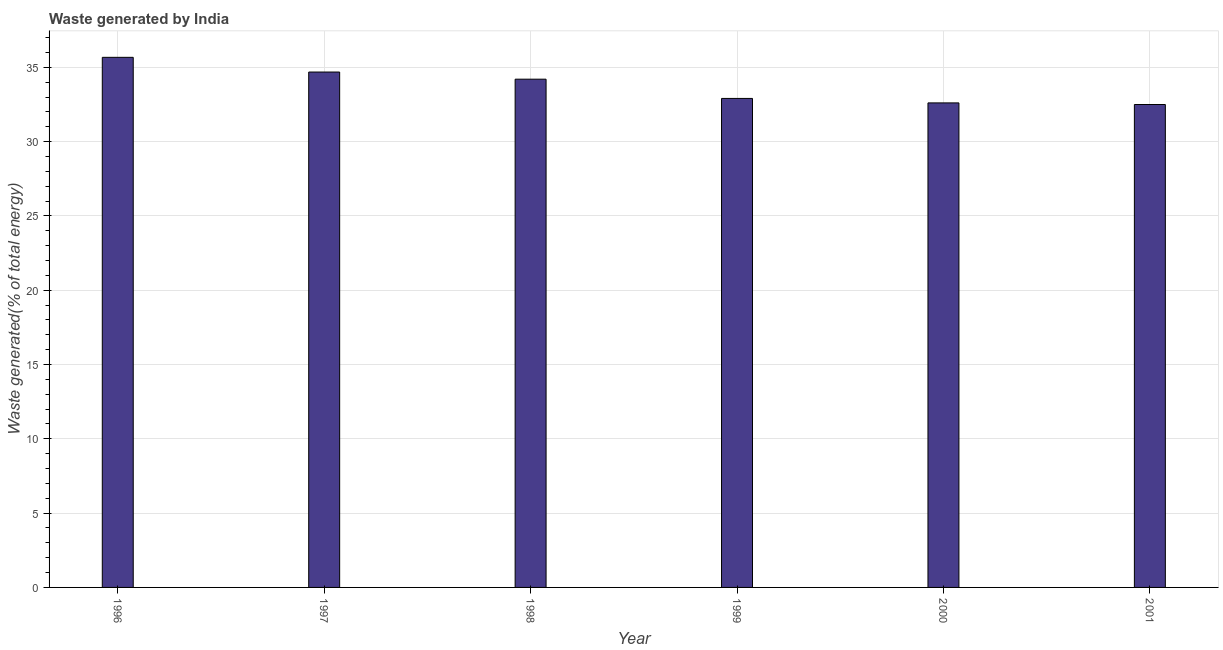What is the title of the graph?
Keep it short and to the point. Waste generated by India. What is the label or title of the Y-axis?
Your answer should be very brief. Waste generated(% of total energy). What is the amount of waste generated in 1996?
Offer a very short reply. 35.67. Across all years, what is the maximum amount of waste generated?
Offer a very short reply. 35.67. Across all years, what is the minimum amount of waste generated?
Your answer should be very brief. 32.5. What is the sum of the amount of waste generated?
Give a very brief answer. 202.57. What is the difference between the amount of waste generated in 1998 and 2000?
Your response must be concise. 1.59. What is the average amount of waste generated per year?
Provide a succinct answer. 33.76. What is the median amount of waste generated?
Provide a short and direct response. 33.55. In how many years, is the amount of waste generated greater than 13 %?
Offer a very short reply. 6. What is the ratio of the amount of waste generated in 1996 to that in 2001?
Offer a terse response. 1.1. Is the amount of waste generated in 1996 less than that in 2001?
Provide a succinct answer. No. What is the difference between the highest and the second highest amount of waste generated?
Offer a terse response. 0.99. What is the difference between the highest and the lowest amount of waste generated?
Make the answer very short. 3.17. In how many years, is the amount of waste generated greater than the average amount of waste generated taken over all years?
Your answer should be compact. 3. How many bars are there?
Offer a very short reply. 6. How many years are there in the graph?
Give a very brief answer. 6. What is the Waste generated(% of total energy) of 1996?
Provide a succinct answer. 35.67. What is the Waste generated(% of total energy) in 1997?
Provide a short and direct response. 34.68. What is the Waste generated(% of total energy) of 1998?
Provide a short and direct response. 34.2. What is the Waste generated(% of total energy) of 1999?
Offer a terse response. 32.91. What is the Waste generated(% of total energy) in 2000?
Give a very brief answer. 32.61. What is the Waste generated(% of total energy) in 2001?
Offer a very short reply. 32.5. What is the difference between the Waste generated(% of total energy) in 1996 and 1997?
Your answer should be compact. 0.99. What is the difference between the Waste generated(% of total energy) in 1996 and 1998?
Make the answer very short. 1.47. What is the difference between the Waste generated(% of total energy) in 1996 and 1999?
Give a very brief answer. 2.77. What is the difference between the Waste generated(% of total energy) in 1996 and 2000?
Ensure brevity in your answer.  3.07. What is the difference between the Waste generated(% of total energy) in 1996 and 2001?
Make the answer very short. 3.17. What is the difference between the Waste generated(% of total energy) in 1997 and 1998?
Offer a terse response. 0.48. What is the difference between the Waste generated(% of total energy) in 1997 and 1999?
Provide a succinct answer. 1.78. What is the difference between the Waste generated(% of total energy) in 1997 and 2000?
Provide a short and direct response. 2.08. What is the difference between the Waste generated(% of total energy) in 1997 and 2001?
Your answer should be compact. 2.19. What is the difference between the Waste generated(% of total energy) in 1998 and 1999?
Provide a succinct answer. 1.3. What is the difference between the Waste generated(% of total energy) in 1998 and 2000?
Provide a succinct answer. 1.6. What is the difference between the Waste generated(% of total energy) in 1998 and 2001?
Offer a very short reply. 1.7. What is the difference between the Waste generated(% of total energy) in 1999 and 2000?
Your answer should be very brief. 0.3. What is the difference between the Waste generated(% of total energy) in 1999 and 2001?
Your answer should be compact. 0.41. What is the difference between the Waste generated(% of total energy) in 2000 and 2001?
Make the answer very short. 0.11. What is the ratio of the Waste generated(% of total energy) in 1996 to that in 1997?
Give a very brief answer. 1.03. What is the ratio of the Waste generated(% of total energy) in 1996 to that in 1998?
Provide a short and direct response. 1.04. What is the ratio of the Waste generated(% of total energy) in 1996 to that in 1999?
Your answer should be very brief. 1.08. What is the ratio of the Waste generated(% of total energy) in 1996 to that in 2000?
Your answer should be very brief. 1.09. What is the ratio of the Waste generated(% of total energy) in 1996 to that in 2001?
Provide a short and direct response. 1.1. What is the ratio of the Waste generated(% of total energy) in 1997 to that in 1998?
Offer a very short reply. 1.01. What is the ratio of the Waste generated(% of total energy) in 1997 to that in 1999?
Your answer should be very brief. 1.05. What is the ratio of the Waste generated(% of total energy) in 1997 to that in 2000?
Your response must be concise. 1.06. What is the ratio of the Waste generated(% of total energy) in 1997 to that in 2001?
Your answer should be very brief. 1.07. What is the ratio of the Waste generated(% of total energy) in 1998 to that in 1999?
Keep it short and to the point. 1.04. What is the ratio of the Waste generated(% of total energy) in 1998 to that in 2000?
Keep it short and to the point. 1.05. What is the ratio of the Waste generated(% of total energy) in 1998 to that in 2001?
Provide a short and direct response. 1.05. 